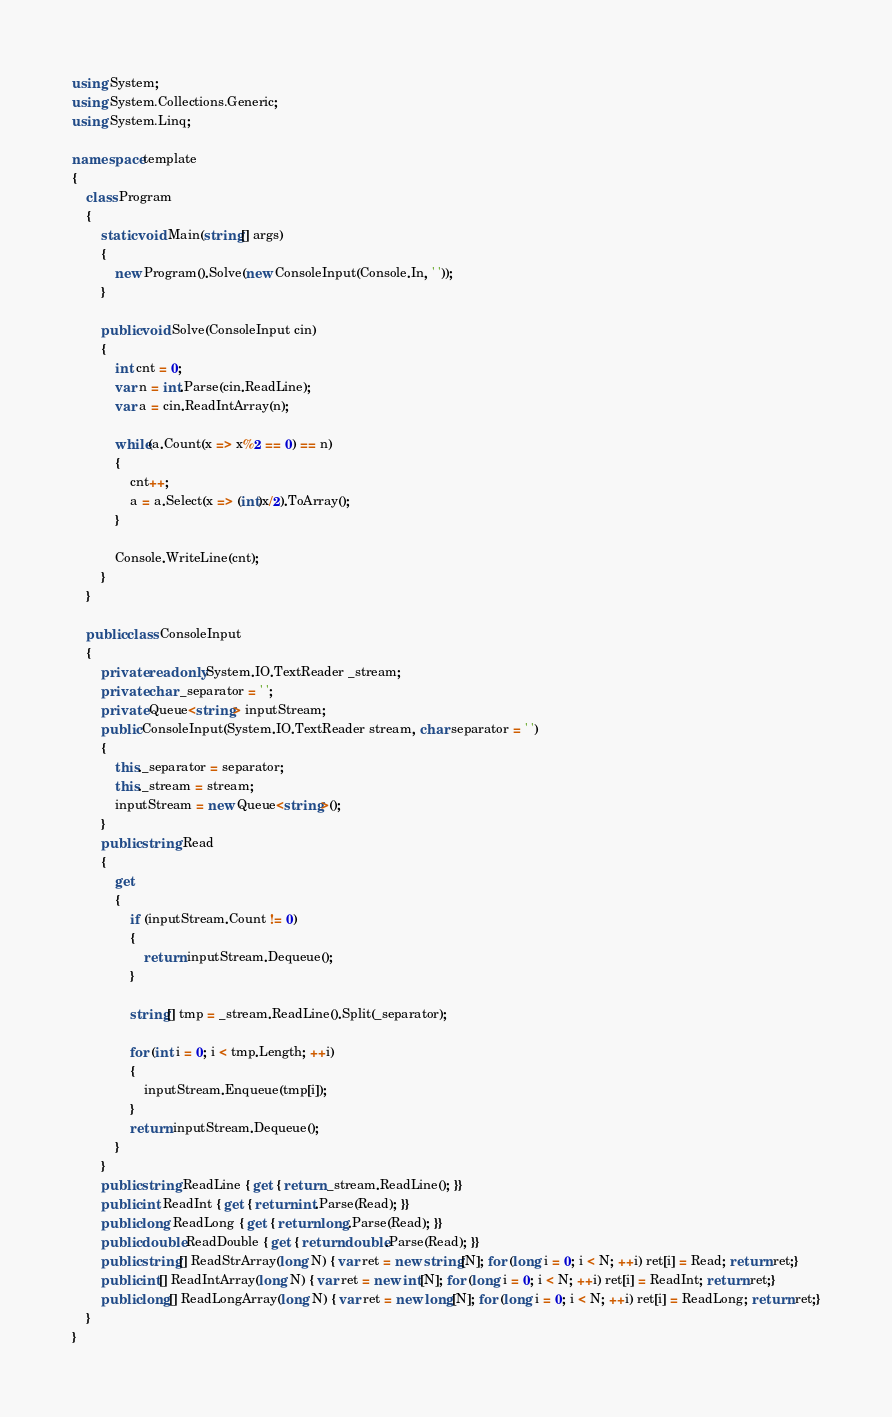<code> <loc_0><loc_0><loc_500><loc_500><_C#_>using System;
using System.Collections.Generic;
using System.Linq;

namespace template
{
    class Program
    {
        static void Main(string[] args)
        {
            new Program().Solve(new ConsoleInput(Console.In, ' '));
        }

        public void Solve(ConsoleInput cin)
        {
            int cnt = 0;
            var n = int.Parse(cin.ReadLine);
            var a = cin.ReadIntArray(n);

            while(a.Count(x => x%2 == 0) == n)
            {
                cnt++;
                a = a.Select(x => (int)x/2).ToArray();
            }

            Console.WriteLine(cnt);
        }
    }

    public class ConsoleInput
    {
        private readonly System.IO.TextReader _stream;
        private char _separator = ' ';
        private Queue<string> inputStream;
        public ConsoleInput(System.IO.TextReader stream, char separator = ' ')
        {
            this._separator = separator;
            this._stream = stream;
            inputStream = new Queue<string>();
        }
        public string Read
        {
            get
            {
                if (inputStream.Count != 0) 
                {
                    return inputStream.Dequeue();
                }

                string[] tmp = _stream.ReadLine().Split(_separator);
                
                for (int i = 0; i < tmp.Length; ++i)
                {
                    inputStream.Enqueue(tmp[i]);
                }
                return inputStream.Dequeue();
            }
        }
        public string ReadLine { get { return _stream.ReadLine(); }}
        public int ReadInt { get { return int.Parse(Read); }}
        public long ReadLong { get { return long.Parse(Read); }}
        public double ReadDouble { get { return double.Parse(Read); }}
        public string[] ReadStrArray(long N) { var ret = new string[N]; for (long i = 0; i < N; ++i) ret[i] = Read; return ret;}
        public int[] ReadIntArray(long N) { var ret = new int[N]; for (long i = 0; i < N; ++i) ret[i] = ReadInt; return ret;}
        public long[] ReadLongArray(long N) { var ret = new long[N]; for (long i = 0; i < N; ++i) ret[i] = ReadLong; return ret;}
    }
}
</code> 